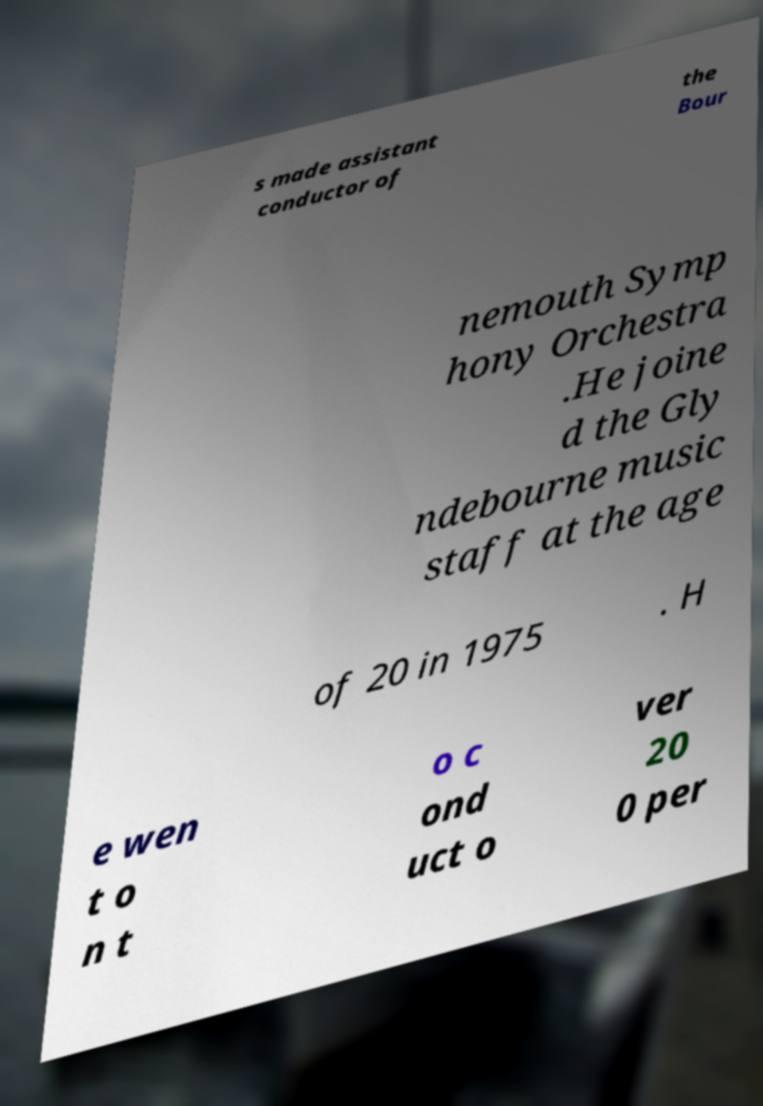Could you assist in decoding the text presented in this image and type it out clearly? s made assistant conductor of the Bour nemouth Symp hony Orchestra .He joine d the Gly ndebourne music staff at the age of 20 in 1975 . H e wen t o n t o c ond uct o ver 20 0 per 